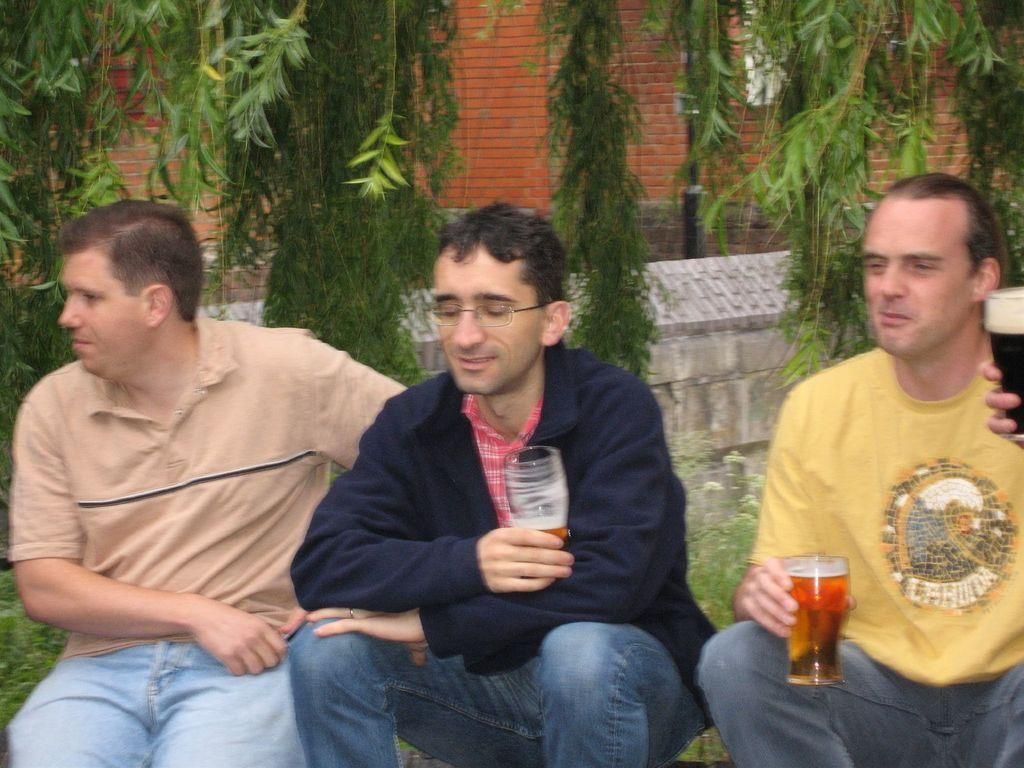How many people are seated in the image? There are three men seated in the image. What are the men holding in their hands? The men are holding glasses in their hands. What type of structure can be seen in the background of the image? There is a building visible in the image. What type of vegetation is present in the image? There are trees present in the image. What type of flesh can be seen in the image? There is no flesh present in the image. 